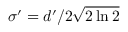Convert formula to latex. <formula><loc_0><loc_0><loc_500><loc_500>\sigma ^ { \prime } = d ^ { \prime } / 2 \sqrt { 2 \ln { 2 } }</formula> 